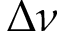Convert formula to latex. <formula><loc_0><loc_0><loc_500><loc_500>\Delta \nu</formula> 